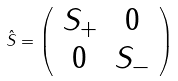<formula> <loc_0><loc_0><loc_500><loc_500>\hat { S } = \left ( \begin{array} { c c } S _ { + } & 0 \\ 0 & S _ { - } \end{array} \right )</formula> 